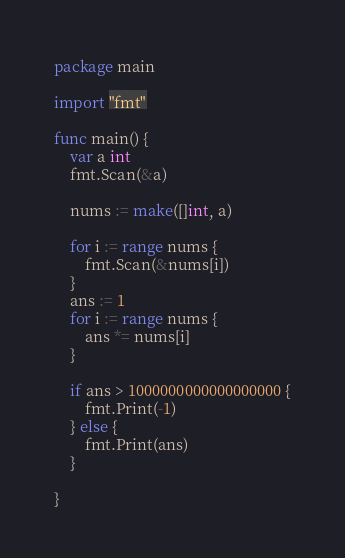<code> <loc_0><loc_0><loc_500><loc_500><_Go_>package main

import "fmt"

func main() {
	var a int
	fmt.Scan(&a)

	nums := make([]int, a)

	for i := range nums {
		fmt.Scan(&nums[i])
	}
	ans := 1
	for i := range nums {
		ans *= nums[i]
	}

	if ans > 1000000000000000000 {
		fmt.Print(-1)
	} else {
		fmt.Print(ans)
	}

}
</code> 